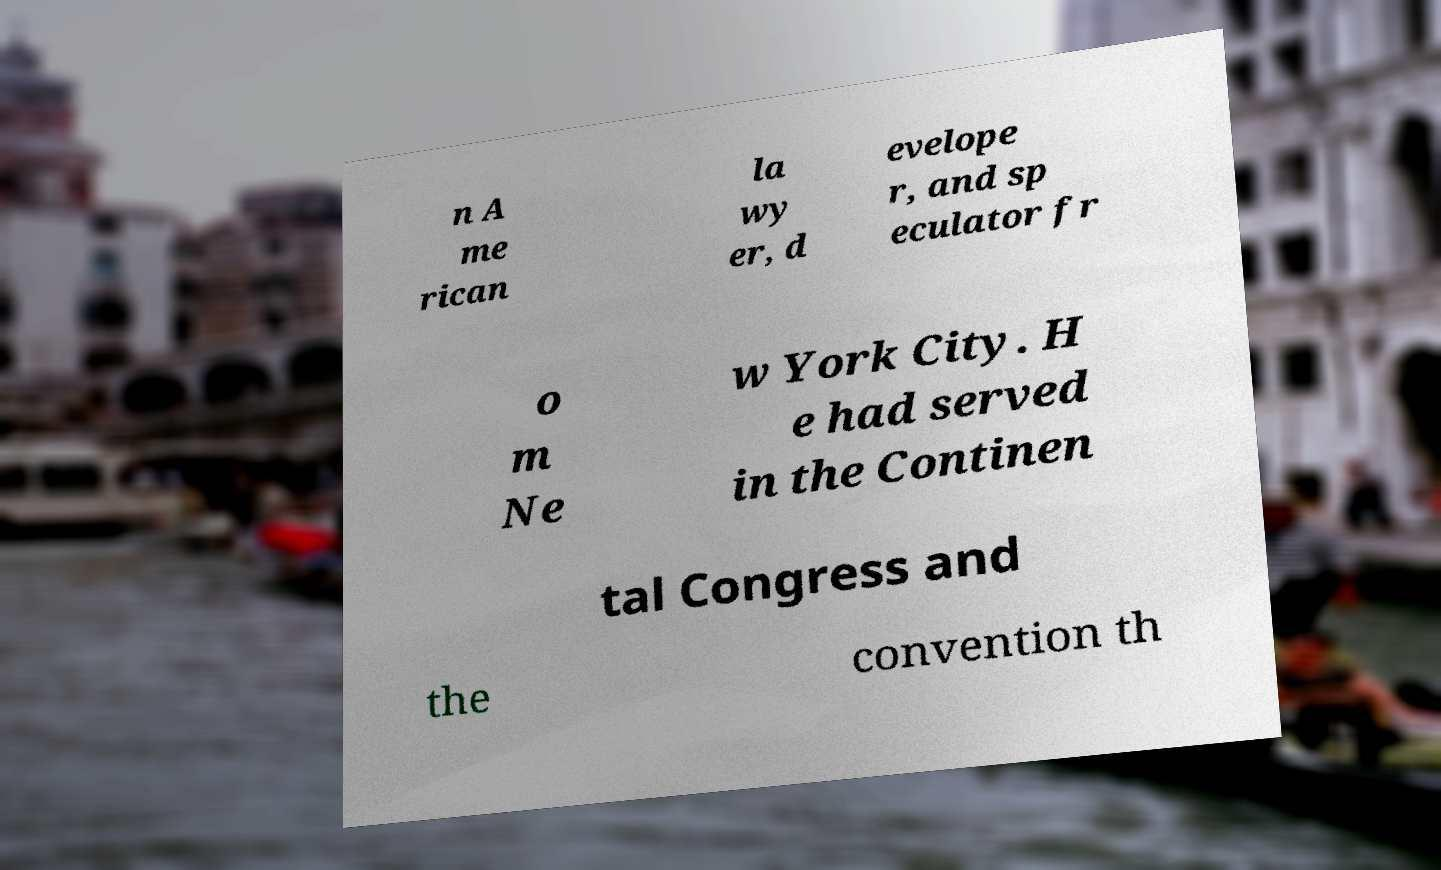Could you assist in decoding the text presented in this image and type it out clearly? n A me rican la wy er, d evelope r, and sp eculator fr o m Ne w York City. H e had served in the Continen tal Congress and the convention th 